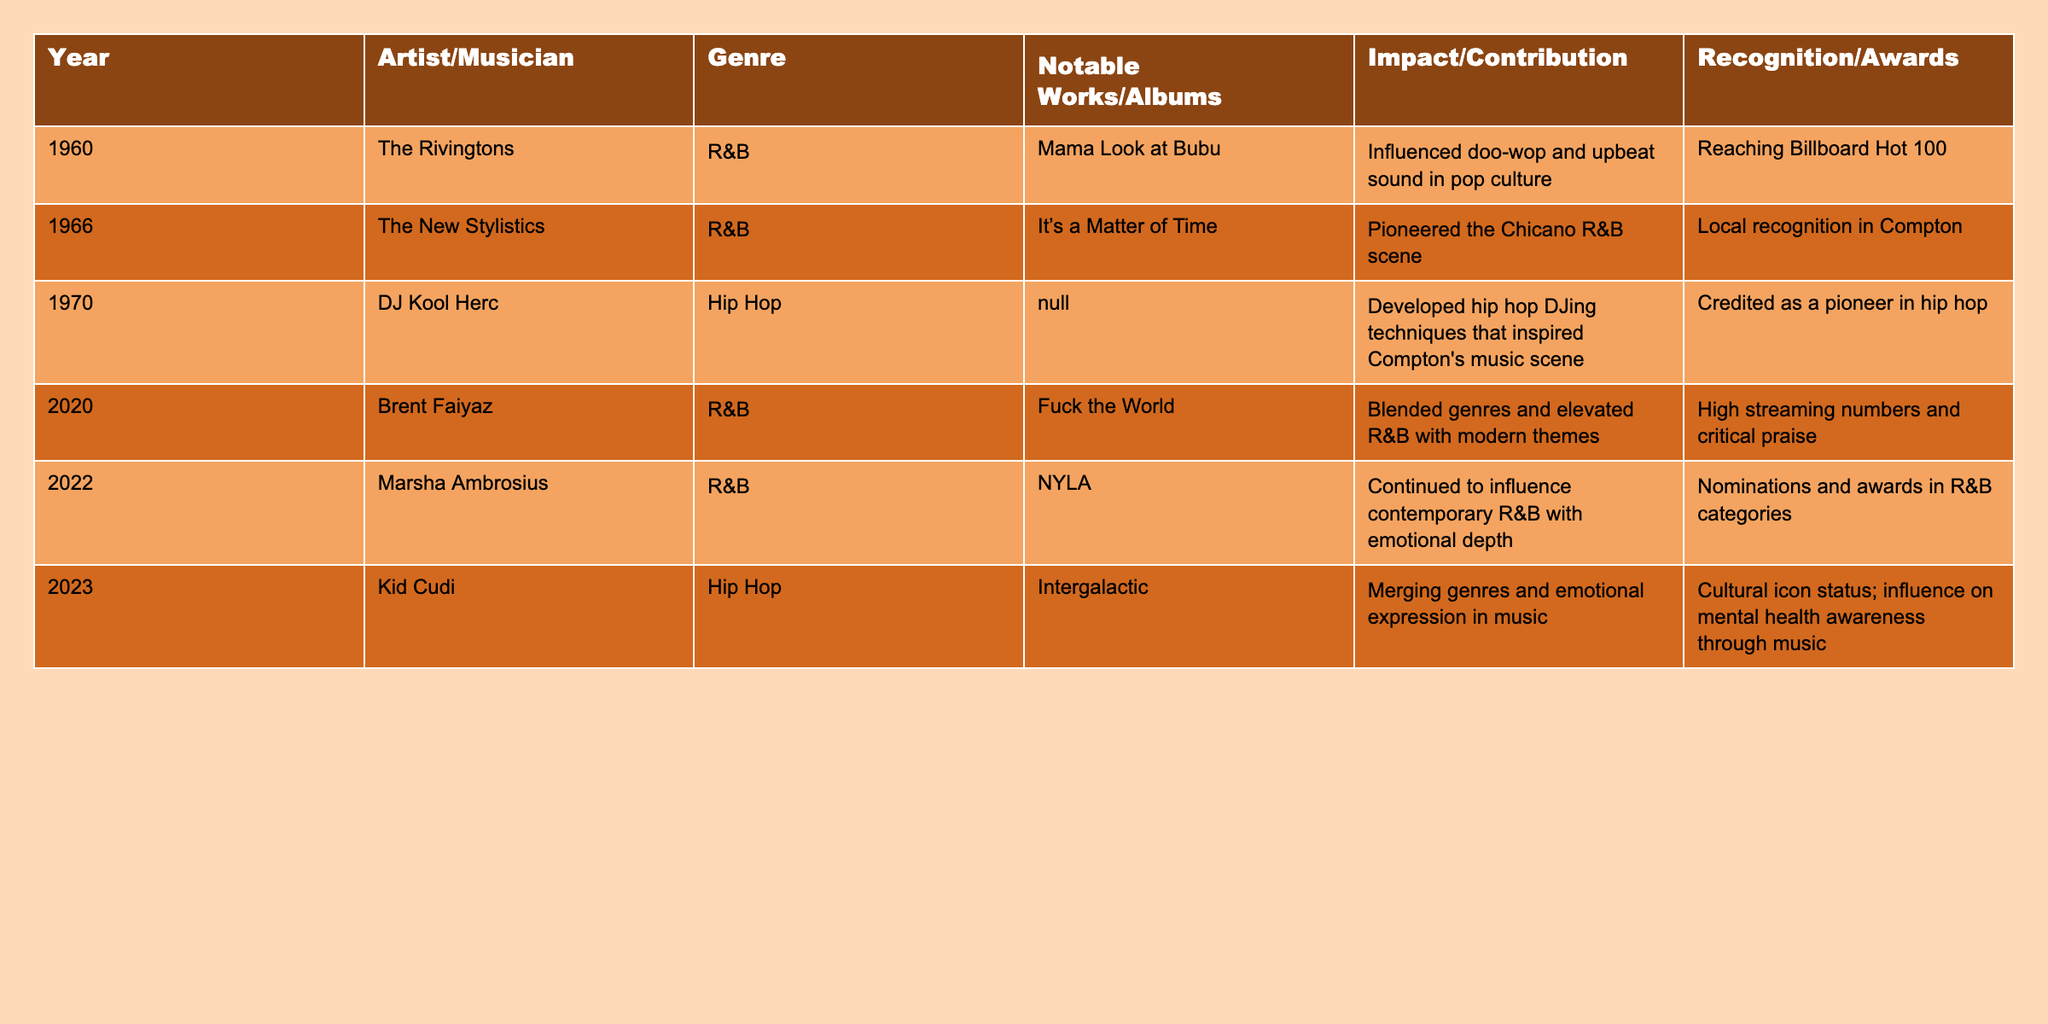What year did DJ Kool Herc contribute to the cultural scene in Compton? According to the table, DJ Kool Herc contributed in the year 1970.
Answer: 1970 Who is recognized for pioneering the Chicano R&B scene? The New Stylistics is noted in the table for pioneering the Chicano R&B scene in 1966.
Answer: The New Stylistics Which artist had notable works that elevated R&B with modern themes? Brent Faiyaz is mentioned as having notable works that blended genres and elevated R&B with modern themes, specifically in 2020.
Answer: Brent Faiyaz How many artists contributed to the music scene from 1960 to 2023 according to the table? There are six artists listed in the table from 1960 to 2023.
Answer: 6 Is Kid Cudi known for influencing mental health awareness through music? Yes, the table states that Kid Cudi has a cultural icon status and influences mental health awareness through music.
Answer: Yes In which year did Marsha Ambrosius receive nominations and awards in R&B categories? The table indicates that Marsha Ambrosius received nominations and awards in R&B categories in 2022.
Answer: 2022 What was the notable work of The Rivingtons and how did they impact pop culture? The Rivingtons' notable work was "Mama Look at Bubu," which influenced doo-wop and upbeat sound in pop culture.
Answer: "Mama Look at Bubu"; impact on doo-wop Between 2020 and 2023, how many artists contributed to the R&B genre? The table shows that two artists, Brent Faiyaz (2020) and Marsha Ambrosius (2022), contributed to the R&B genre during these years.
Answer: 2 What was the main contribution of DJ Kool Herc, and how is he recognized? The main contribution of DJ Kool Herc was developing hip hop DJing techniques, and he is recognized as a pioneer in hip hop.
Answer: Developing hip hop DJing techniques; pioneer in hip hop Which artist had the earliest contribution listed in the table and what was their genre? The earliest contribution listed is by The Rivingtons in 1960, and their genre was R&B.
Answer: The Rivingtons; R&B 